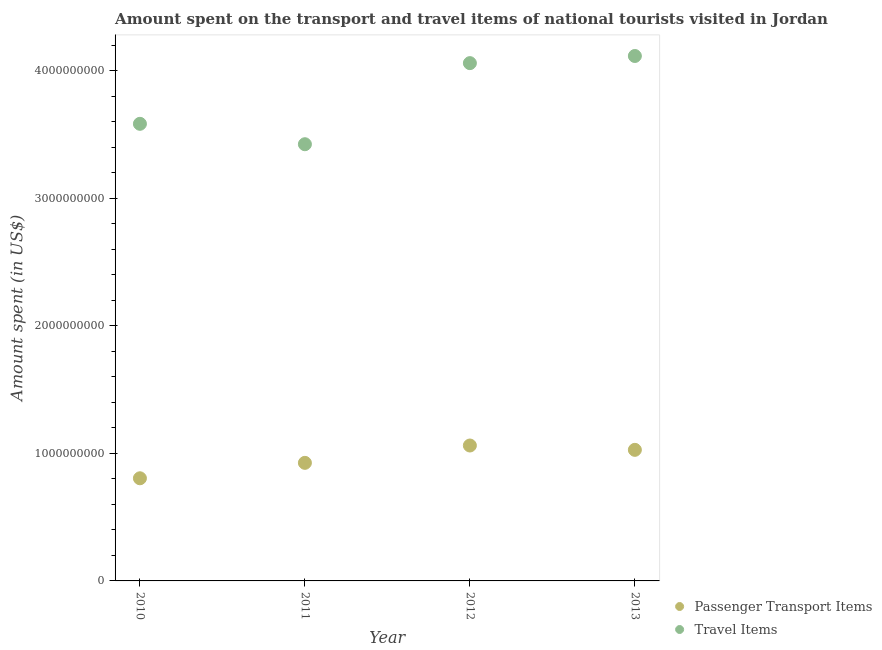What is the amount spent in travel items in 2010?
Offer a terse response. 3.58e+09. Across all years, what is the maximum amount spent in travel items?
Your response must be concise. 4.12e+09. Across all years, what is the minimum amount spent in travel items?
Make the answer very short. 3.42e+09. In which year was the amount spent on passenger transport items minimum?
Provide a succinct answer. 2010. What is the total amount spent in travel items in the graph?
Provide a short and direct response. 1.52e+1. What is the difference between the amount spent on passenger transport items in 2011 and that in 2013?
Make the answer very short. -1.02e+08. What is the difference between the amount spent in travel items in 2010 and the amount spent on passenger transport items in 2012?
Give a very brief answer. 2.52e+09. What is the average amount spent on passenger transport items per year?
Keep it short and to the point. 9.55e+08. In the year 2013, what is the difference between the amount spent on passenger transport items and amount spent in travel items?
Give a very brief answer. -3.09e+09. In how many years, is the amount spent on passenger transport items greater than 3800000000 US$?
Your response must be concise. 0. What is the ratio of the amount spent in travel items in 2010 to that in 2012?
Offer a terse response. 0.88. Is the amount spent in travel items in 2012 less than that in 2013?
Give a very brief answer. Yes. What is the difference between the highest and the second highest amount spent in travel items?
Offer a terse response. 5.60e+07. What is the difference between the highest and the lowest amount spent in travel items?
Make the answer very short. 6.92e+08. In how many years, is the amount spent on passenger transport items greater than the average amount spent on passenger transport items taken over all years?
Offer a terse response. 2. Is the amount spent in travel items strictly less than the amount spent on passenger transport items over the years?
Your response must be concise. No. Where does the legend appear in the graph?
Your answer should be very brief. Bottom right. How are the legend labels stacked?
Offer a terse response. Vertical. What is the title of the graph?
Your answer should be very brief. Amount spent on the transport and travel items of national tourists visited in Jordan. What is the label or title of the X-axis?
Ensure brevity in your answer.  Year. What is the label or title of the Y-axis?
Provide a succinct answer. Amount spent (in US$). What is the Amount spent (in US$) of Passenger Transport Items in 2010?
Offer a very short reply. 8.05e+08. What is the Amount spent (in US$) in Travel Items in 2010?
Provide a succinct answer. 3.58e+09. What is the Amount spent (in US$) of Passenger Transport Items in 2011?
Provide a short and direct response. 9.26e+08. What is the Amount spent (in US$) in Travel Items in 2011?
Make the answer very short. 3.42e+09. What is the Amount spent (in US$) in Passenger Transport Items in 2012?
Provide a short and direct response. 1.06e+09. What is the Amount spent (in US$) in Travel Items in 2012?
Your response must be concise. 4.06e+09. What is the Amount spent (in US$) of Passenger Transport Items in 2013?
Provide a short and direct response. 1.03e+09. What is the Amount spent (in US$) in Travel Items in 2013?
Ensure brevity in your answer.  4.12e+09. Across all years, what is the maximum Amount spent (in US$) of Passenger Transport Items?
Give a very brief answer. 1.06e+09. Across all years, what is the maximum Amount spent (in US$) in Travel Items?
Your answer should be compact. 4.12e+09. Across all years, what is the minimum Amount spent (in US$) in Passenger Transport Items?
Ensure brevity in your answer.  8.05e+08. Across all years, what is the minimum Amount spent (in US$) in Travel Items?
Ensure brevity in your answer.  3.42e+09. What is the total Amount spent (in US$) of Passenger Transport Items in the graph?
Offer a very short reply. 3.82e+09. What is the total Amount spent (in US$) in Travel Items in the graph?
Your answer should be compact. 1.52e+1. What is the difference between the Amount spent (in US$) in Passenger Transport Items in 2010 and that in 2011?
Provide a short and direct response. -1.21e+08. What is the difference between the Amount spent (in US$) of Travel Items in 2010 and that in 2011?
Provide a succinct answer. 1.60e+08. What is the difference between the Amount spent (in US$) in Passenger Transport Items in 2010 and that in 2012?
Give a very brief answer. -2.57e+08. What is the difference between the Amount spent (in US$) in Travel Items in 2010 and that in 2012?
Ensure brevity in your answer.  -4.76e+08. What is the difference between the Amount spent (in US$) of Passenger Transport Items in 2010 and that in 2013?
Provide a short and direct response. -2.23e+08. What is the difference between the Amount spent (in US$) in Travel Items in 2010 and that in 2013?
Offer a terse response. -5.32e+08. What is the difference between the Amount spent (in US$) of Passenger Transport Items in 2011 and that in 2012?
Provide a succinct answer. -1.36e+08. What is the difference between the Amount spent (in US$) of Travel Items in 2011 and that in 2012?
Provide a succinct answer. -6.36e+08. What is the difference between the Amount spent (in US$) in Passenger Transport Items in 2011 and that in 2013?
Make the answer very short. -1.02e+08. What is the difference between the Amount spent (in US$) of Travel Items in 2011 and that in 2013?
Ensure brevity in your answer.  -6.92e+08. What is the difference between the Amount spent (in US$) of Passenger Transport Items in 2012 and that in 2013?
Your response must be concise. 3.40e+07. What is the difference between the Amount spent (in US$) of Travel Items in 2012 and that in 2013?
Your answer should be compact. -5.60e+07. What is the difference between the Amount spent (in US$) of Passenger Transport Items in 2010 and the Amount spent (in US$) of Travel Items in 2011?
Offer a terse response. -2.62e+09. What is the difference between the Amount spent (in US$) of Passenger Transport Items in 2010 and the Amount spent (in US$) of Travel Items in 2012?
Provide a short and direct response. -3.26e+09. What is the difference between the Amount spent (in US$) in Passenger Transport Items in 2010 and the Amount spent (in US$) in Travel Items in 2013?
Make the answer very short. -3.31e+09. What is the difference between the Amount spent (in US$) of Passenger Transport Items in 2011 and the Amount spent (in US$) of Travel Items in 2012?
Make the answer very short. -3.14e+09. What is the difference between the Amount spent (in US$) in Passenger Transport Items in 2011 and the Amount spent (in US$) in Travel Items in 2013?
Offer a terse response. -3.19e+09. What is the difference between the Amount spent (in US$) of Passenger Transport Items in 2012 and the Amount spent (in US$) of Travel Items in 2013?
Provide a succinct answer. -3.06e+09. What is the average Amount spent (in US$) of Passenger Transport Items per year?
Offer a very short reply. 9.55e+08. What is the average Amount spent (in US$) of Travel Items per year?
Your answer should be very brief. 3.80e+09. In the year 2010, what is the difference between the Amount spent (in US$) of Passenger Transport Items and Amount spent (in US$) of Travel Items?
Your response must be concise. -2.78e+09. In the year 2011, what is the difference between the Amount spent (in US$) in Passenger Transport Items and Amount spent (in US$) in Travel Items?
Make the answer very short. -2.50e+09. In the year 2012, what is the difference between the Amount spent (in US$) of Passenger Transport Items and Amount spent (in US$) of Travel Items?
Give a very brief answer. -3.00e+09. In the year 2013, what is the difference between the Amount spent (in US$) in Passenger Transport Items and Amount spent (in US$) in Travel Items?
Provide a succinct answer. -3.09e+09. What is the ratio of the Amount spent (in US$) of Passenger Transport Items in 2010 to that in 2011?
Your answer should be very brief. 0.87. What is the ratio of the Amount spent (in US$) of Travel Items in 2010 to that in 2011?
Ensure brevity in your answer.  1.05. What is the ratio of the Amount spent (in US$) of Passenger Transport Items in 2010 to that in 2012?
Provide a succinct answer. 0.76. What is the ratio of the Amount spent (in US$) in Travel Items in 2010 to that in 2012?
Offer a terse response. 0.88. What is the ratio of the Amount spent (in US$) of Passenger Transport Items in 2010 to that in 2013?
Give a very brief answer. 0.78. What is the ratio of the Amount spent (in US$) in Travel Items in 2010 to that in 2013?
Keep it short and to the point. 0.87. What is the ratio of the Amount spent (in US$) of Passenger Transport Items in 2011 to that in 2012?
Keep it short and to the point. 0.87. What is the ratio of the Amount spent (in US$) in Travel Items in 2011 to that in 2012?
Provide a short and direct response. 0.84. What is the ratio of the Amount spent (in US$) in Passenger Transport Items in 2011 to that in 2013?
Provide a short and direct response. 0.9. What is the ratio of the Amount spent (in US$) in Travel Items in 2011 to that in 2013?
Offer a very short reply. 0.83. What is the ratio of the Amount spent (in US$) in Passenger Transport Items in 2012 to that in 2013?
Keep it short and to the point. 1.03. What is the ratio of the Amount spent (in US$) of Travel Items in 2012 to that in 2013?
Your response must be concise. 0.99. What is the difference between the highest and the second highest Amount spent (in US$) in Passenger Transport Items?
Provide a succinct answer. 3.40e+07. What is the difference between the highest and the second highest Amount spent (in US$) of Travel Items?
Your answer should be compact. 5.60e+07. What is the difference between the highest and the lowest Amount spent (in US$) in Passenger Transport Items?
Ensure brevity in your answer.  2.57e+08. What is the difference between the highest and the lowest Amount spent (in US$) of Travel Items?
Give a very brief answer. 6.92e+08. 